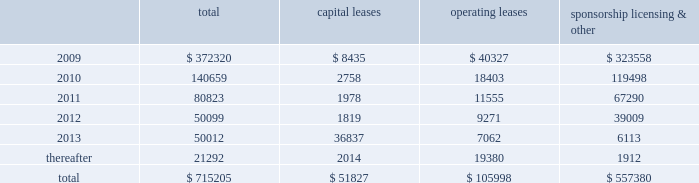Mastercard incorporated notes to consolidated financial statements 2014 ( continued ) ( in thousands , except percent and per share data ) note 17 .
Commitments at december 31 , 2008 , the company had the following future minimum payments due under non-cancelable agreements : capital leases operating leases sponsorship , licensing & .
Included in the table above are capital leases with imputed interest expense of $ 9483 and a net present value of minimum lease payments of $ 42343 .
In addition , at december 31 , 2008 , $ 92300 of the future minimum payments in the table above for leases , sponsorship , licensing and other agreements was accrued .
Consolidated rental expense for the company 2019s office space , which is recognized on a straight line basis over the life of the lease , was approximately $ 42905 , $ 35614 and $ 31467 for the years ended december 31 , 2008 , 2007 and 2006 , respectively .
Consolidated lease expense for automobiles , computer equipment and office equipment was $ 7694 , $ 7679 and $ 8419 for the years ended december 31 , 2008 , 2007 and 2006 , respectively .
In january 2003 , mastercard purchased a building in kansas city , missouri for approximately $ 23572 .
The building is a co-processing data center which replaced a back-up data center in lake success , new york .
During 2003 , mastercard entered into agreements with the city of kansas city for ( i ) the sale-leaseback of the building and related equipment which totaled $ 36382 and ( ii ) the purchase of municipal bonds for the same amount which have been classified as municipal bonds held-to-maturity .
The agreements enabled mastercard to secure state and local financial benefits .
No gain or loss was recorded in connection with the agreements .
The leaseback has been accounted for as a capital lease as the agreement contains a bargain purchase option at the end of the ten-year lease term on april 1 , 2013 .
The building and related equipment are being depreciated over their estimated economic life in accordance with the company 2019s policy .
Rent of $ 1819 is due annually and is equal to the interest due on the municipal bonds .
The future minimum lease payments are $ 45781 and are included in the table above .
A portion of the building was subleased to the original building owner for a five-year term with a renewal option .
As of december 31 , 2008 , the future minimum sublease rental income is $ 4416 .
Note 18 .
Obligations under litigation settlements on october 27 , 2008 , mastercard and visa inc .
( 201cvisa 201d ) entered into a settlement agreement ( the 201cdiscover settlement 201d ) with discover financial services , inc .
( 201cdiscover 201d ) relating to the u.s .
Federal antitrust litigation amongst the parties .
The discover settlement ended all litigation between the parties for a total of $ 2750000 .
In july 2008 , mastercard and visa had entered into a judgment sharing agreement that allocated responsibility for any judgment or settlement of the discover action between the parties .
Accordingly , the mastercard share of the discover settlement was $ 862500 , which was paid to discover in november 2008 .
In addition , in connection with the discover settlement , morgan stanley , discover 2019s former parent company , paid mastercard $ 35000 in november 2008 , pursuant to a separate agreement .
The net impact of $ 827500 is included in litigation settlements for the year ended december 31 , 2008. .
Considering the years 2012 and 2013 , what is the variation observed in the operating leases? 
Rationale: it is the difference between each year's operating leases .
Computations: (9271 - 7062)
Answer: 2209.0. 